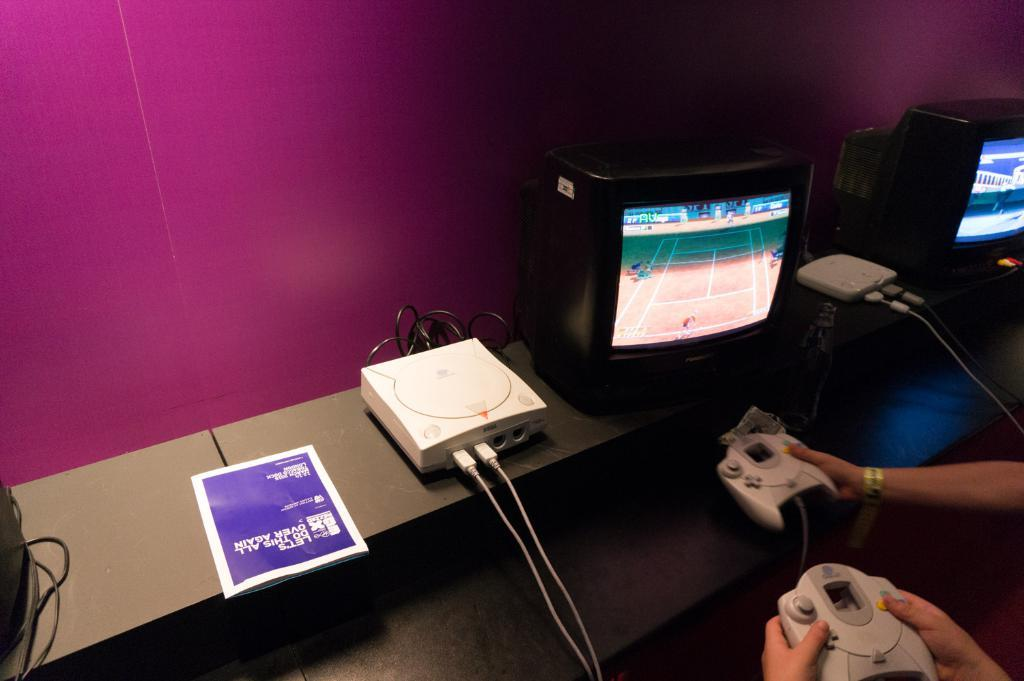<image>
Share a concise interpretation of the image provided. Twp person are holding game controllers and on the shelf is a sheet of paper with the first word of LET'S on it. 